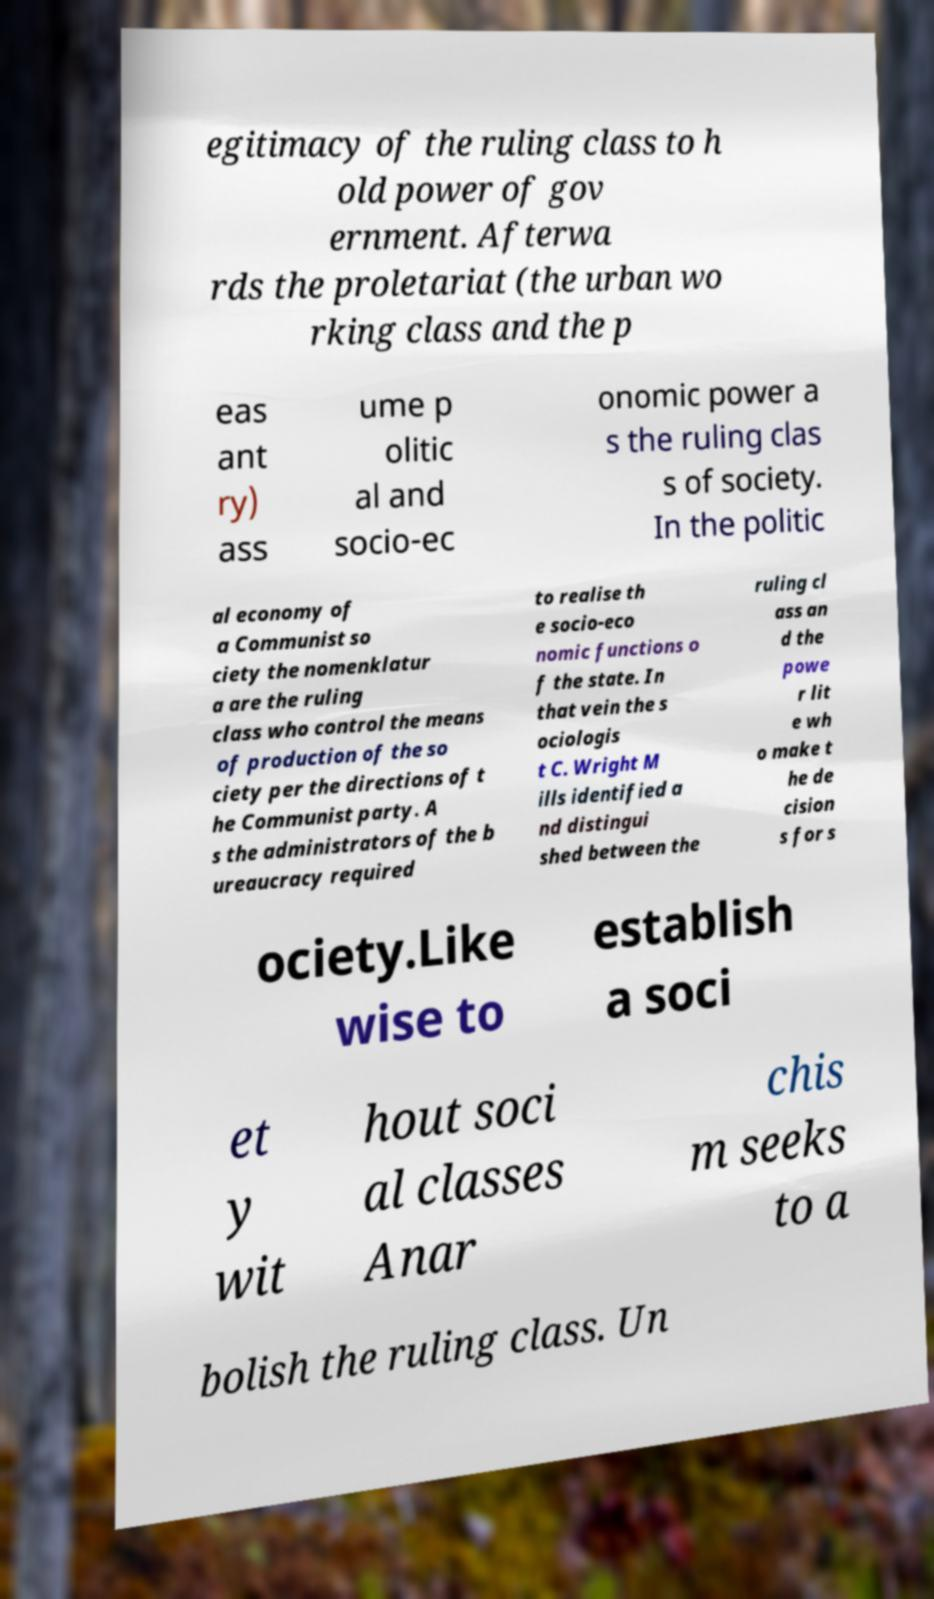Can you accurately transcribe the text from the provided image for me? egitimacy of the ruling class to h old power of gov ernment. Afterwa rds the proletariat (the urban wo rking class and the p eas ant ry) ass ume p olitic al and socio-ec onomic power a s the ruling clas s of society. In the politic al economy of a Communist so ciety the nomenklatur a are the ruling class who control the means of production of the so ciety per the directions of t he Communist party. A s the administrators of the b ureaucracy required to realise th e socio-eco nomic functions o f the state. In that vein the s ociologis t C. Wright M ills identified a nd distingui shed between the ruling cl ass an d the powe r lit e wh o make t he de cision s for s ociety.Like wise to establish a soci et y wit hout soci al classes Anar chis m seeks to a bolish the ruling class. Un 